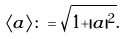Convert formula to latex. <formula><loc_0><loc_0><loc_500><loc_500>\langle a \rangle & \colon = \sqrt { 1 + | a | ^ { 2 } } .</formula> 